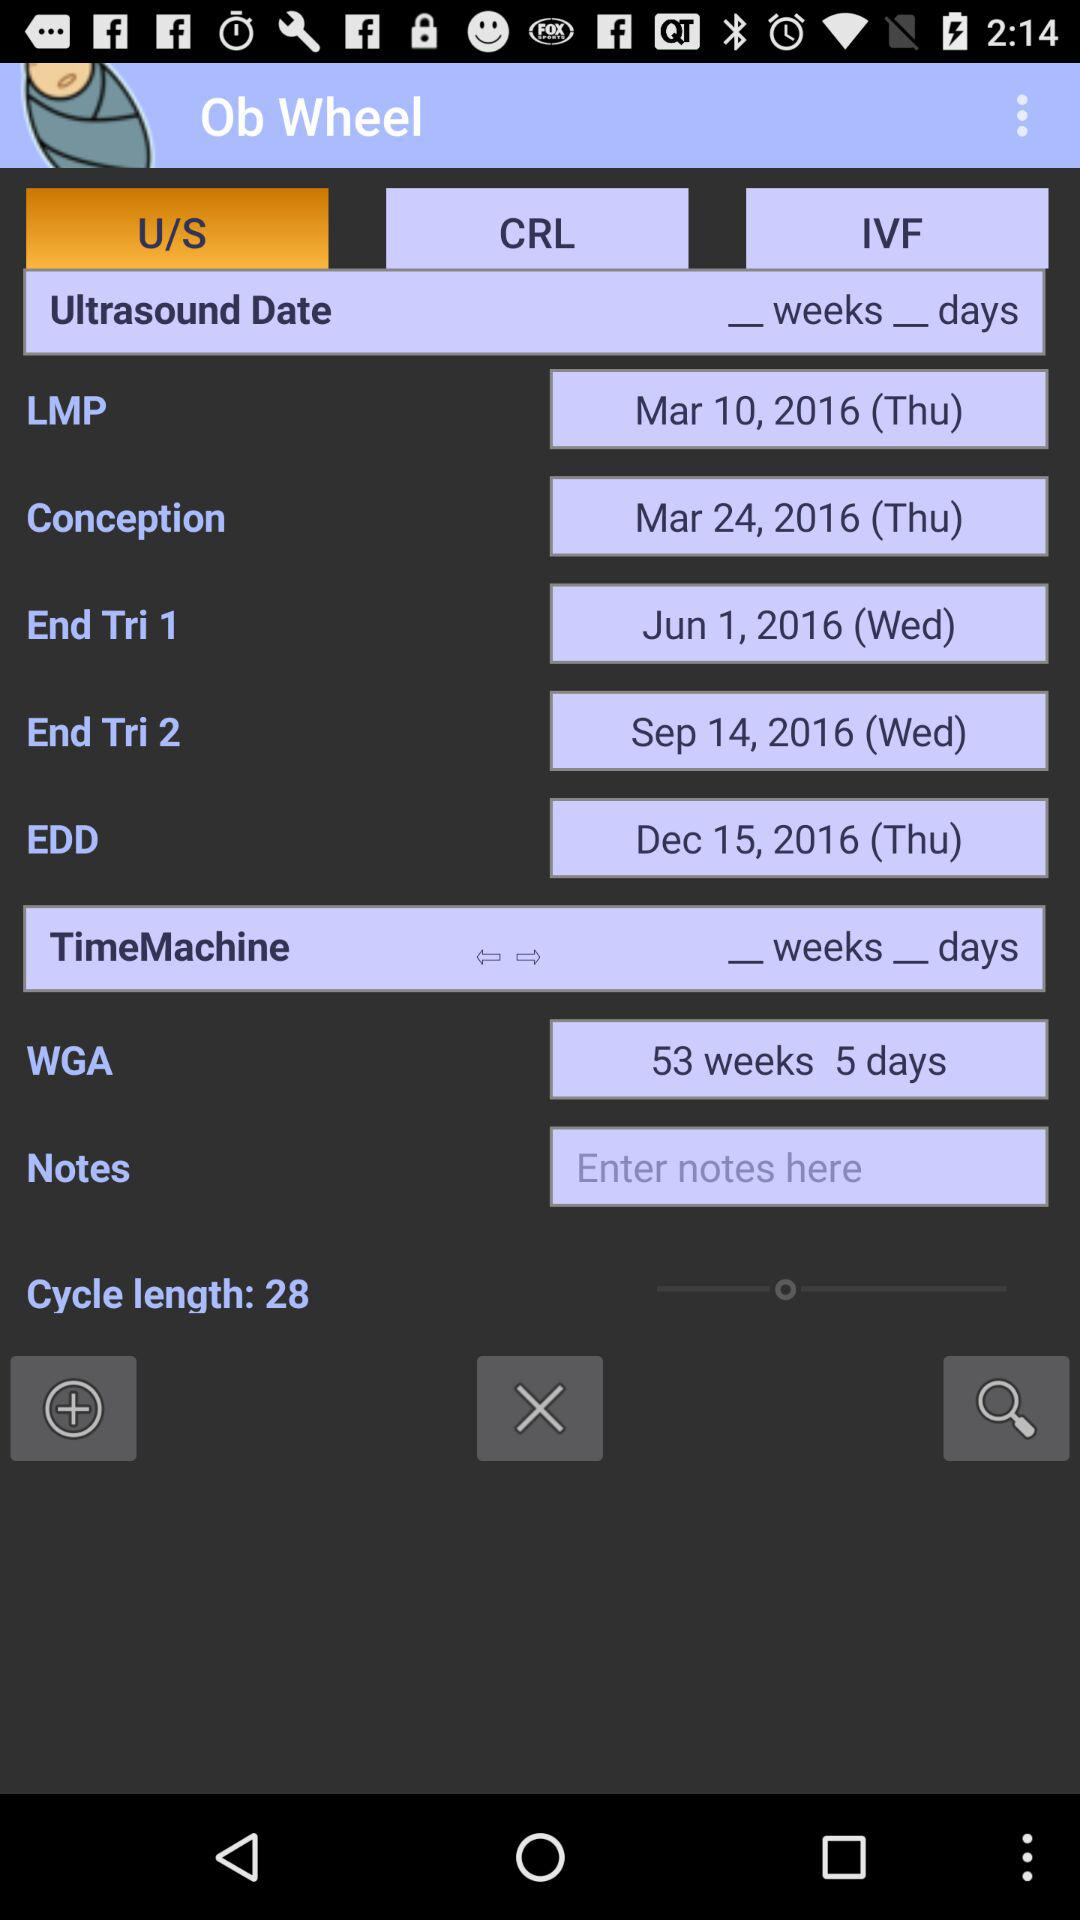How many days apart are the LMP and Conception dates? Typically, conception is assumed to occur about 14 days after the start of the last menstrual period (LMP), which is reflected in standard medical practice when estimating gestational age. However, this can vary from woman to woman and depends on individual cycles. The provided image confirms this standard estimation with the LMP date of March 10, 2016, and the conception date of March 24, 2016, exactly 14 days apart. This fits within the common range for a typical menstrual cycle. 